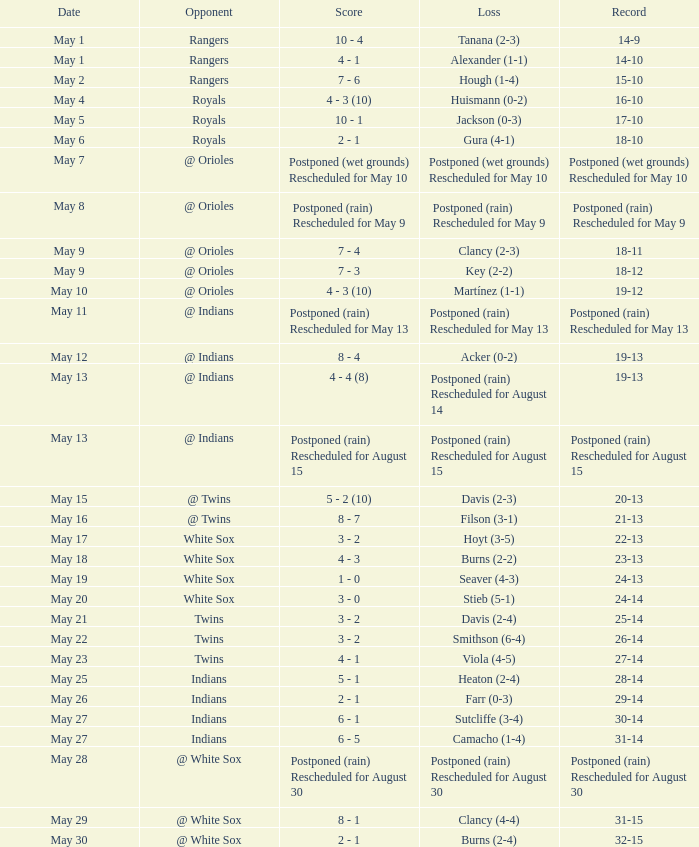What was the date of the match when the score was 31-15? May 29. 